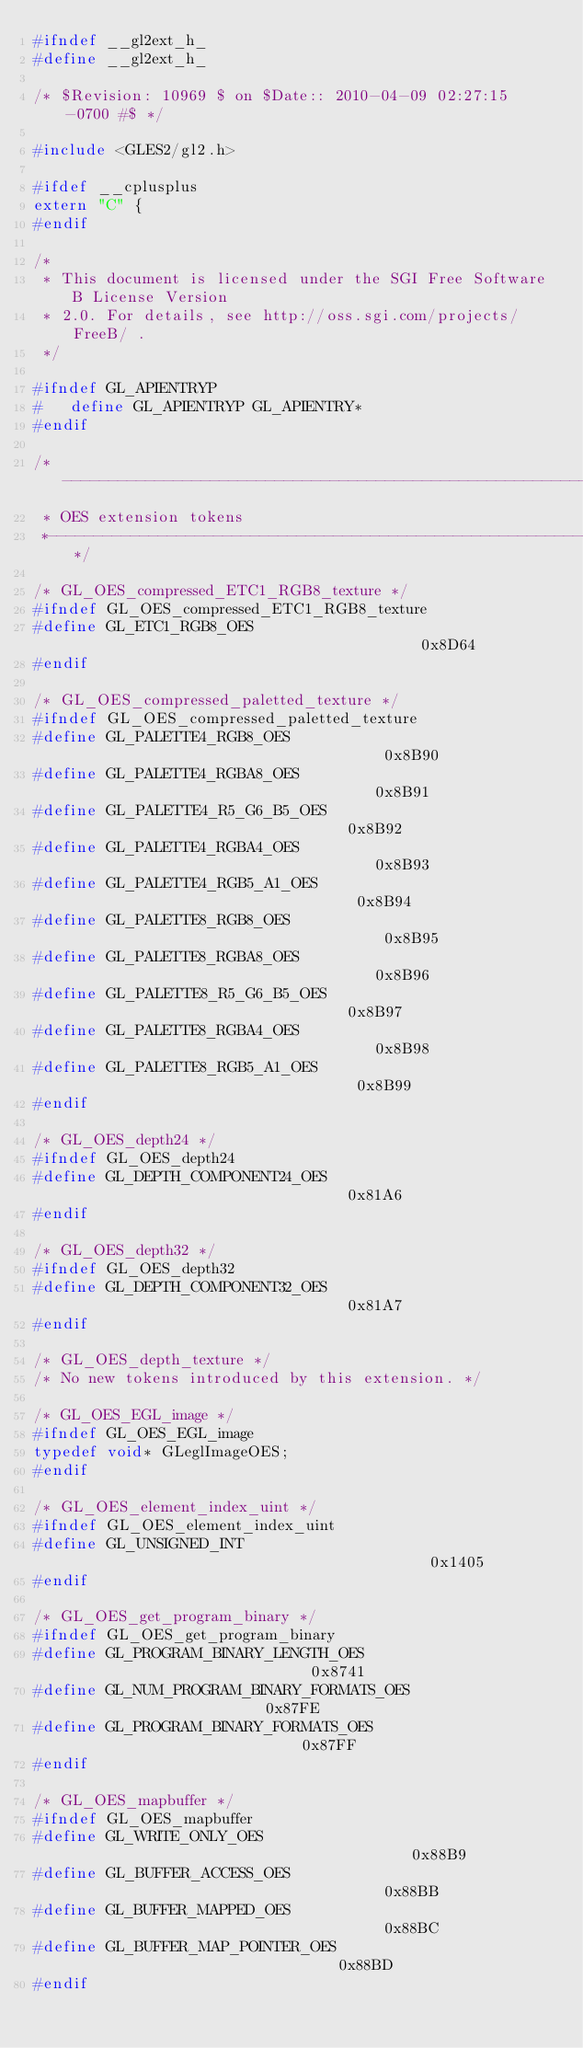Convert code to text. <code><loc_0><loc_0><loc_500><loc_500><_C_>#ifndef __gl2ext_h_
#define __gl2ext_h_

/* $Revision: 10969 $ on $Date:: 2010-04-09 02:27:15 -0700 #$ */

#include <GLES2/gl2.h>

#ifdef __cplusplus
extern "C" {
#endif

/*
 * This document is licensed under the SGI Free Software B License Version
 * 2.0. For details, see http://oss.sgi.com/projects/FreeB/ .
 */

#ifndef GL_APIENTRYP
#   define GL_APIENTRYP GL_APIENTRY*
#endif

/*------------------------------------------------------------------------*
 * OES extension tokens
 *------------------------------------------------------------------------*/

/* GL_OES_compressed_ETC1_RGB8_texture */
#ifndef GL_OES_compressed_ETC1_RGB8_texture
#define GL_ETC1_RGB8_OES                                        0x8D64
#endif

/* GL_OES_compressed_paletted_texture */
#ifndef GL_OES_compressed_paletted_texture
#define GL_PALETTE4_RGB8_OES                                    0x8B90
#define GL_PALETTE4_RGBA8_OES                                   0x8B91
#define GL_PALETTE4_R5_G6_B5_OES                                0x8B92
#define GL_PALETTE4_RGBA4_OES                                   0x8B93
#define GL_PALETTE4_RGB5_A1_OES                                 0x8B94
#define GL_PALETTE8_RGB8_OES                                    0x8B95
#define GL_PALETTE8_RGBA8_OES                                   0x8B96
#define GL_PALETTE8_R5_G6_B5_OES                                0x8B97
#define GL_PALETTE8_RGBA4_OES                                   0x8B98
#define GL_PALETTE8_RGB5_A1_OES                                 0x8B99
#endif

/* GL_OES_depth24 */
#ifndef GL_OES_depth24
#define GL_DEPTH_COMPONENT24_OES                                0x81A6
#endif

/* GL_OES_depth32 */
#ifndef GL_OES_depth32
#define GL_DEPTH_COMPONENT32_OES                                0x81A7
#endif

/* GL_OES_depth_texture */
/* No new tokens introduced by this extension. */

/* GL_OES_EGL_image */
#ifndef GL_OES_EGL_image
typedef void* GLeglImageOES;
#endif

/* GL_OES_element_index_uint */
#ifndef GL_OES_element_index_uint
#define GL_UNSIGNED_INT                                         0x1405
#endif

/* GL_OES_get_program_binary */
#ifndef GL_OES_get_program_binary
#define GL_PROGRAM_BINARY_LENGTH_OES                            0x8741
#define GL_NUM_PROGRAM_BINARY_FORMATS_OES                       0x87FE
#define GL_PROGRAM_BINARY_FORMATS_OES                           0x87FF
#endif

/* GL_OES_mapbuffer */
#ifndef GL_OES_mapbuffer
#define GL_WRITE_ONLY_OES                                       0x88B9
#define GL_BUFFER_ACCESS_OES                                    0x88BB
#define GL_BUFFER_MAPPED_OES                                    0x88BC
#define GL_BUFFER_MAP_POINTER_OES                               0x88BD
#endif
</code> 